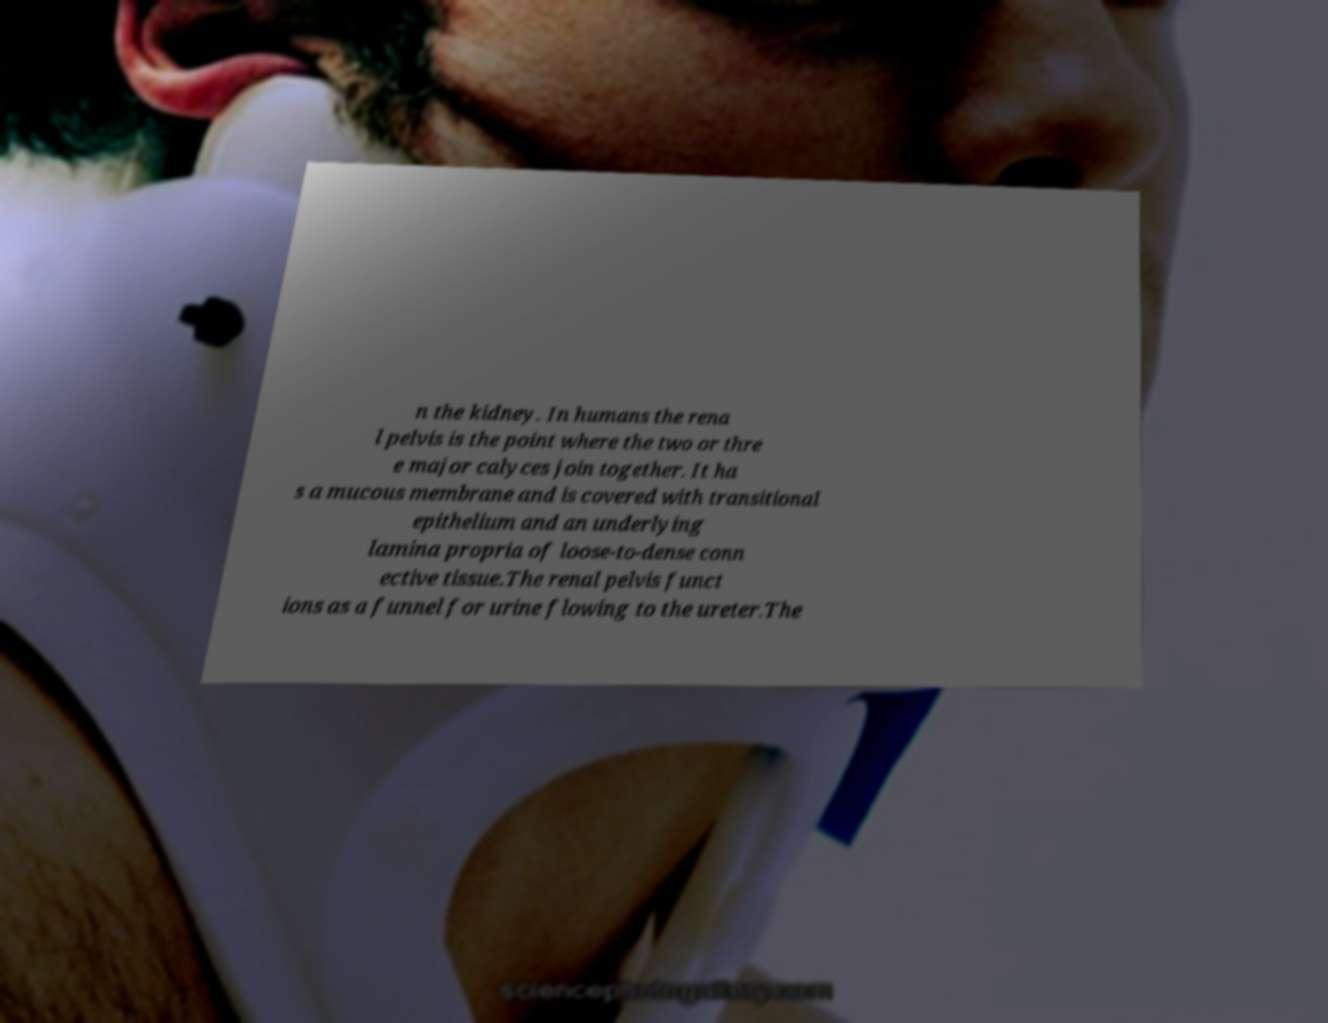Can you read and provide the text displayed in the image?This photo seems to have some interesting text. Can you extract and type it out for me? n the kidney. In humans the rena l pelvis is the point where the two or thre e major calyces join together. It ha s a mucous membrane and is covered with transitional epithelium and an underlying lamina propria of loose-to-dense conn ective tissue.The renal pelvis funct ions as a funnel for urine flowing to the ureter.The 